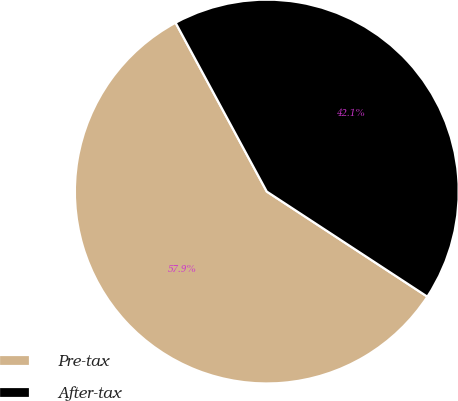<chart> <loc_0><loc_0><loc_500><loc_500><pie_chart><fcel>Pre-tax<fcel>After-tax<nl><fcel>57.89%<fcel>42.11%<nl></chart> 